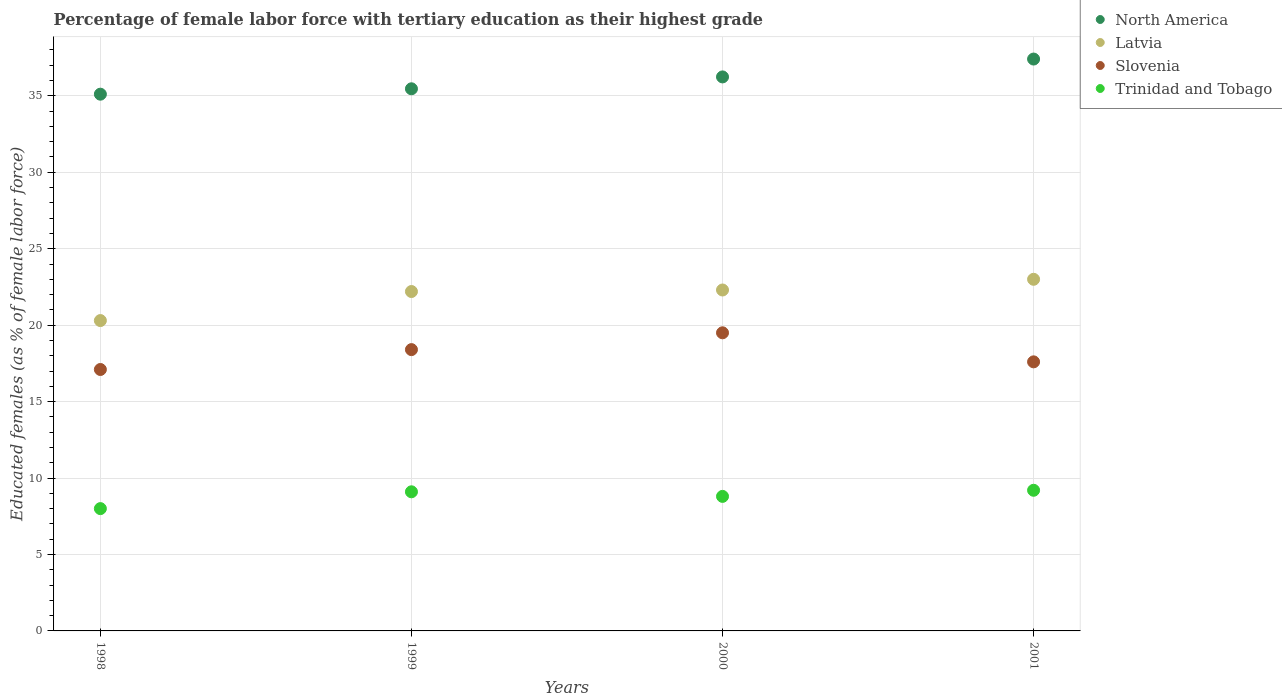How many different coloured dotlines are there?
Provide a short and direct response. 4. Is the number of dotlines equal to the number of legend labels?
Offer a very short reply. Yes. What is the percentage of female labor force with tertiary education in Slovenia in 2001?
Provide a short and direct response. 17.6. Across all years, what is the minimum percentage of female labor force with tertiary education in North America?
Give a very brief answer. 35.11. In which year was the percentage of female labor force with tertiary education in Latvia minimum?
Give a very brief answer. 1998. What is the total percentage of female labor force with tertiary education in North America in the graph?
Keep it short and to the point. 144.21. What is the difference between the percentage of female labor force with tertiary education in Trinidad and Tobago in 1998 and that in 2001?
Your response must be concise. -1.2. What is the difference between the percentage of female labor force with tertiary education in Trinidad and Tobago in 1998 and the percentage of female labor force with tertiary education in North America in 2001?
Your answer should be very brief. -29.41. What is the average percentage of female labor force with tertiary education in Trinidad and Tobago per year?
Your answer should be very brief. 8.78. In the year 2000, what is the difference between the percentage of female labor force with tertiary education in Slovenia and percentage of female labor force with tertiary education in Latvia?
Offer a terse response. -2.8. In how many years, is the percentage of female labor force with tertiary education in Slovenia greater than 12 %?
Provide a short and direct response. 4. What is the ratio of the percentage of female labor force with tertiary education in Latvia in 1998 to that in 2001?
Provide a succinct answer. 0.88. What is the difference between the highest and the second highest percentage of female labor force with tertiary education in Trinidad and Tobago?
Keep it short and to the point. 0.1. What is the difference between the highest and the lowest percentage of female labor force with tertiary education in Slovenia?
Your answer should be very brief. 2.4. In how many years, is the percentage of female labor force with tertiary education in Slovenia greater than the average percentage of female labor force with tertiary education in Slovenia taken over all years?
Provide a succinct answer. 2. Is the sum of the percentage of female labor force with tertiary education in North America in 1998 and 1999 greater than the maximum percentage of female labor force with tertiary education in Latvia across all years?
Offer a very short reply. Yes. Is it the case that in every year, the sum of the percentage of female labor force with tertiary education in Latvia and percentage of female labor force with tertiary education in Slovenia  is greater than the percentage of female labor force with tertiary education in Trinidad and Tobago?
Provide a succinct answer. Yes. Does the percentage of female labor force with tertiary education in Trinidad and Tobago monotonically increase over the years?
Ensure brevity in your answer.  No. Is the percentage of female labor force with tertiary education in North America strictly greater than the percentage of female labor force with tertiary education in Trinidad and Tobago over the years?
Your answer should be compact. Yes. Is the percentage of female labor force with tertiary education in North America strictly less than the percentage of female labor force with tertiary education in Slovenia over the years?
Provide a succinct answer. No. How many years are there in the graph?
Keep it short and to the point. 4. Does the graph contain any zero values?
Offer a very short reply. No. How are the legend labels stacked?
Your response must be concise. Vertical. What is the title of the graph?
Give a very brief answer. Percentage of female labor force with tertiary education as their highest grade. What is the label or title of the X-axis?
Make the answer very short. Years. What is the label or title of the Y-axis?
Offer a very short reply. Educated females (as % of female labor force). What is the Educated females (as % of female labor force) in North America in 1998?
Your answer should be very brief. 35.11. What is the Educated females (as % of female labor force) of Latvia in 1998?
Make the answer very short. 20.3. What is the Educated females (as % of female labor force) in Slovenia in 1998?
Your answer should be compact. 17.1. What is the Educated females (as % of female labor force) in North America in 1999?
Provide a short and direct response. 35.46. What is the Educated females (as % of female labor force) of Latvia in 1999?
Make the answer very short. 22.2. What is the Educated females (as % of female labor force) in Slovenia in 1999?
Your answer should be very brief. 18.4. What is the Educated females (as % of female labor force) in Trinidad and Tobago in 1999?
Your answer should be very brief. 9.1. What is the Educated females (as % of female labor force) in North America in 2000?
Your answer should be compact. 36.24. What is the Educated females (as % of female labor force) of Latvia in 2000?
Make the answer very short. 22.3. What is the Educated females (as % of female labor force) of Slovenia in 2000?
Your answer should be very brief. 19.5. What is the Educated females (as % of female labor force) in Trinidad and Tobago in 2000?
Make the answer very short. 8.8. What is the Educated females (as % of female labor force) in North America in 2001?
Offer a terse response. 37.41. What is the Educated females (as % of female labor force) of Latvia in 2001?
Offer a terse response. 23. What is the Educated females (as % of female labor force) of Slovenia in 2001?
Keep it short and to the point. 17.6. What is the Educated females (as % of female labor force) in Trinidad and Tobago in 2001?
Provide a short and direct response. 9.2. Across all years, what is the maximum Educated females (as % of female labor force) of North America?
Make the answer very short. 37.41. Across all years, what is the maximum Educated females (as % of female labor force) in Latvia?
Give a very brief answer. 23. Across all years, what is the maximum Educated females (as % of female labor force) in Slovenia?
Your answer should be very brief. 19.5. Across all years, what is the maximum Educated females (as % of female labor force) of Trinidad and Tobago?
Offer a very short reply. 9.2. Across all years, what is the minimum Educated females (as % of female labor force) of North America?
Your response must be concise. 35.11. Across all years, what is the minimum Educated females (as % of female labor force) in Latvia?
Offer a terse response. 20.3. Across all years, what is the minimum Educated females (as % of female labor force) in Slovenia?
Your answer should be very brief. 17.1. What is the total Educated females (as % of female labor force) in North America in the graph?
Provide a succinct answer. 144.21. What is the total Educated females (as % of female labor force) in Latvia in the graph?
Make the answer very short. 87.8. What is the total Educated females (as % of female labor force) of Slovenia in the graph?
Your response must be concise. 72.6. What is the total Educated females (as % of female labor force) of Trinidad and Tobago in the graph?
Your answer should be compact. 35.1. What is the difference between the Educated females (as % of female labor force) of North America in 1998 and that in 1999?
Give a very brief answer. -0.35. What is the difference between the Educated females (as % of female labor force) of Latvia in 1998 and that in 1999?
Provide a short and direct response. -1.9. What is the difference between the Educated females (as % of female labor force) of Trinidad and Tobago in 1998 and that in 1999?
Your response must be concise. -1.1. What is the difference between the Educated females (as % of female labor force) of North America in 1998 and that in 2000?
Give a very brief answer. -1.13. What is the difference between the Educated females (as % of female labor force) of Trinidad and Tobago in 1998 and that in 2000?
Your response must be concise. -0.8. What is the difference between the Educated females (as % of female labor force) in North America in 1998 and that in 2001?
Your answer should be very brief. -2.3. What is the difference between the Educated females (as % of female labor force) of Latvia in 1998 and that in 2001?
Your answer should be very brief. -2.7. What is the difference between the Educated females (as % of female labor force) of Slovenia in 1998 and that in 2001?
Your answer should be compact. -0.5. What is the difference between the Educated females (as % of female labor force) of Trinidad and Tobago in 1998 and that in 2001?
Your answer should be compact. -1.2. What is the difference between the Educated females (as % of female labor force) in North America in 1999 and that in 2000?
Offer a terse response. -0.78. What is the difference between the Educated females (as % of female labor force) in Latvia in 1999 and that in 2000?
Keep it short and to the point. -0.1. What is the difference between the Educated females (as % of female labor force) of North America in 1999 and that in 2001?
Offer a very short reply. -1.95. What is the difference between the Educated females (as % of female labor force) of Latvia in 1999 and that in 2001?
Give a very brief answer. -0.8. What is the difference between the Educated females (as % of female labor force) in Slovenia in 1999 and that in 2001?
Offer a terse response. 0.8. What is the difference between the Educated females (as % of female labor force) of North America in 2000 and that in 2001?
Provide a short and direct response. -1.17. What is the difference between the Educated females (as % of female labor force) of North America in 1998 and the Educated females (as % of female labor force) of Latvia in 1999?
Offer a terse response. 12.91. What is the difference between the Educated females (as % of female labor force) of North America in 1998 and the Educated females (as % of female labor force) of Slovenia in 1999?
Offer a terse response. 16.71. What is the difference between the Educated females (as % of female labor force) in North America in 1998 and the Educated females (as % of female labor force) in Trinidad and Tobago in 1999?
Provide a succinct answer. 26.01. What is the difference between the Educated females (as % of female labor force) in Slovenia in 1998 and the Educated females (as % of female labor force) in Trinidad and Tobago in 1999?
Give a very brief answer. 8. What is the difference between the Educated females (as % of female labor force) in North America in 1998 and the Educated females (as % of female labor force) in Latvia in 2000?
Make the answer very short. 12.81. What is the difference between the Educated females (as % of female labor force) of North America in 1998 and the Educated females (as % of female labor force) of Slovenia in 2000?
Your answer should be very brief. 15.61. What is the difference between the Educated females (as % of female labor force) of North America in 1998 and the Educated females (as % of female labor force) of Trinidad and Tobago in 2000?
Offer a terse response. 26.31. What is the difference between the Educated females (as % of female labor force) in North America in 1998 and the Educated females (as % of female labor force) in Latvia in 2001?
Make the answer very short. 12.11. What is the difference between the Educated females (as % of female labor force) in North America in 1998 and the Educated females (as % of female labor force) in Slovenia in 2001?
Provide a succinct answer. 17.51. What is the difference between the Educated females (as % of female labor force) of North America in 1998 and the Educated females (as % of female labor force) of Trinidad and Tobago in 2001?
Provide a succinct answer. 25.91. What is the difference between the Educated females (as % of female labor force) of Latvia in 1998 and the Educated females (as % of female labor force) of Trinidad and Tobago in 2001?
Give a very brief answer. 11.1. What is the difference between the Educated females (as % of female labor force) of North America in 1999 and the Educated females (as % of female labor force) of Latvia in 2000?
Give a very brief answer. 13.16. What is the difference between the Educated females (as % of female labor force) of North America in 1999 and the Educated females (as % of female labor force) of Slovenia in 2000?
Offer a very short reply. 15.96. What is the difference between the Educated females (as % of female labor force) in North America in 1999 and the Educated females (as % of female labor force) in Trinidad and Tobago in 2000?
Provide a succinct answer. 26.66. What is the difference between the Educated females (as % of female labor force) in Latvia in 1999 and the Educated females (as % of female labor force) in Trinidad and Tobago in 2000?
Your answer should be compact. 13.4. What is the difference between the Educated females (as % of female labor force) in North America in 1999 and the Educated females (as % of female labor force) in Latvia in 2001?
Your answer should be very brief. 12.46. What is the difference between the Educated females (as % of female labor force) in North America in 1999 and the Educated females (as % of female labor force) in Slovenia in 2001?
Your answer should be compact. 17.86. What is the difference between the Educated females (as % of female labor force) of North America in 1999 and the Educated females (as % of female labor force) of Trinidad and Tobago in 2001?
Offer a very short reply. 26.26. What is the difference between the Educated females (as % of female labor force) in Latvia in 1999 and the Educated females (as % of female labor force) in Trinidad and Tobago in 2001?
Offer a very short reply. 13. What is the difference between the Educated females (as % of female labor force) of Slovenia in 1999 and the Educated females (as % of female labor force) of Trinidad and Tobago in 2001?
Ensure brevity in your answer.  9.2. What is the difference between the Educated females (as % of female labor force) of North America in 2000 and the Educated females (as % of female labor force) of Latvia in 2001?
Provide a succinct answer. 13.24. What is the difference between the Educated females (as % of female labor force) in North America in 2000 and the Educated females (as % of female labor force) in Slovenia in 2001?
Your response must be concise. 18.64. What is the difference between the Educated females (as % of female labor force) of North America in 2000 and the Educated females (as % of female labor force) of Trinidad and Tobago in 2001?
Offer a very short reply. 27.04. What is the difference between the Educated females (as % of female labor force) in Latvia in 2000 and the Educated females (as % of female labor force) in Slovenia in 2001?
Your answer should be very brief. 4.7. What is the difference between the Educated females (as % of female labor force) of Latvia in 2000 and the Educated females (as % of female labor force) of Trinidad and Tobago in 2001?
Your answer should be very brief. 13.1. What is the difference between the Educated females (as % of female labor force) in Slovenia in 2000 and the Educated females (as % of female labor force) in Trinidad and Tobago in 2001?
Offer a terse response. 10.3. What is the average Educated females (as % of female labor force) in North America per year?
Make the answer very short. 36.05. What is the average Educated females (as % of female labor force) in Latvia per year?
Provide a short and direct response. 21.95. What is the average Educated females (as % of female labor force) in Slovenia per year?
Provide a short and direct response. 18.15. What is the average Educated females (as % of female labor force) of Trinidad and Tobago per year?
Provide a short and direct response. 8.78. In the year 1998, what is the difference between the Educated females (as % of female labor force) in North America and Educated females (as % of female labor force) in Latvia?
Make the answer very short. 14.81. In the year 1998, what is the difference between the Educated females (as % of female labor force) of North America and Educated females (as % of female labor force) of Slovenia?
Offer a very short reply. 18.01. In the year 1998, what is the difference between the Educated females (as % of female labor force) of North America and Educated females (as % of female labor force) of Trinidad and Tobago?
Keep it short and to the point. 27.11. In the year 1998, what is the difference between the Educated females (as % of female labor force) in Latvia and Educated females (as % of female labor force) in Slovenia?
Offer a very short reply. 3.2. In the year 1998, what is the difference between the Educated females (as % of female labor force) of Latvia and Educated females (as % of female labor force) of Trinidad and Tobago?
Offer a very short reply. 12.3. In the year 1999, what is the difference between the Educated females (as % of female labor force) in North America and Educated females (as % of female labor force) in Latvia?
Keep it short and to the point. 13.26. In the year 1999, what is the difference between the Educated females (as % of female labor force) of North America and Educated females (as % of female labor force) of Slovenia?
Provide a short and direct response. 17.06. In the year 1999, what is the difference between the Educated females (as % of female labor force) in North America and Educated females (as % of female labor force) in Trinidad and Tobago?
Give a very brief answer. 26.36. In the year 1999, what is the difference between the Educated females (as % of female labor force) in Latvia and Educated females (as % of female labor force) in Trinidad and Tobago?
Offer a terse response. 13.1. In the year 1999, what is the difference between the Educated females (as % of female labor force) of Slovenia and Educated females (as % of female labor force) of Trinidad and Tobago?
Your answer should be compact. 9.3. In the year 2000, what is the difference between the Educated females (as % of female labor force) of North America and Educated females (as % of female labor force) of Latvia?
Keep it short and to the point. 13.94. In the year 2000, what is the difference between the Educated females (as % of female labor force) of North America and Educated females (as % of female labor force) of Slovenia?
Your answer should be compact. 16.74. In the year 2000, what is the difference between the Educated females (as % of female labor force) in North America and Educated females (as % of female labor force) in Trinidad and Tobago?
Ensure brevity in your answer.  27.44. In the year 2000, what is the difference between the Educated females (as % of female labor force) in Latvia and Educated females (as % of female labor force) in Slovenia?
Offer a terse response. 2.8. In the year 2000, what is the difference between the Educated females (as % of female labor force) of Latvia and Educated females (as % of female labor force) of Trinidad and Tobago?
Give a very brief answer. 13.5. In the year 2001, what is the difference between the Educated females (as % of female labor force) of North America and Educated females (as % of female labor force) of Latvia?
Keep it short and to the point. 14.41. In the year 2001, what is the difference between the Educated females (as % of female labor force) in North America and Educated females (as % of female labor force) in Slovenia?
Ensure brevity in your answer.  19.81. In the year 2001, what is the difference between the Educated females (as % of female labor force) in North America and Educated females (as % of female labor force) in Trinidad and Tobago?
Give a very brief answer. 28.21. In the year 2001, what is the difference between the Educated females (as % of female labor force) in Latvia and Educated females (as % of female labor force) in Slovenia?
Keep it short and to the point. 5.4. In the year 2001, what is the difference between the Educated females (as % of female labor force) of Slovenia and Educated females (as % of female labor force) of Trinidad and Tobago?
Provide a short and direct response. 8.4. What is the ratio of the Educated females (as % of female labor force) in North America in 1998 to that in 1999?
Your response must be concise. 0.99. What is the ratio of the Educated females (as % of female labor force) in Latvia in 1998 to that in 1999?
Ensure brevity in your answer.  0.91. What is the ratio of the Educated females (as % of female labor force) in Slovenia in 1998 to that in 1999?
Give a very brief answer. 0.93. What is the ratio of the Educated females (as % of female labor force) of Trinidad and Tobago in 1998 to that in 1999?
Provide a succinct answer. 0.88. What is the ratio of the Educated females (as % of female labor force) in North America in 1998 to that in 2000?
Provide a short and direct response. 0.97. What is the ratio of the Educated females (as % of female labor force) of Latvia in 1998 to that in 2000?
Make the answer very short. 0.91. What is the ratio of the Educated females (as % of female labor force) in Slovenia in 1998 to that in 2000?
Your response must be concise. 0.88. What is the ratio of the Educated females (as % of female labor force) of North America in 1998 to that in 2001?
Your answer should be very brief. 0.94. What is the ratio of the Educated females (as % of female labor force) in Latvia in 1998 to that in 2001?
Offer a very short reply. 0.88. What is the ratio of the Educated females (as % of female labor force) in Slovenia in 1998 to that in 2001?
Provide a short and direct response. 0.97. What is the ratio of the Educated females (as % of female labor force) in Trinidad and Tobago in 1998 to that in 2001?
Offer a very short reply. 0.87. What is the ratio of the Educated females (as % of female labor force) of North America in 1999 to that in 2000?
Provide a succinct answer. 0.98. What is the ratio of the Educated females (as % of female labor force) in Latvia in 1999 to that in 2000?
Your response must be concise. 1. What is the ratio of the Educated females (as % of female labor force) of Slovenia in 1999 to that in 2000?
Give a very brief answer. 0.94. What is the ratio of the Educated females (as % of female labor force) of Trinidad and Tobago in 1999 to that in 2000?
Provide a succinct answer. 1.03. What is the ratio of the Educated females (as % of female labor force) of North America in 1999 to that in 2001?
Offer a very short reply. 0.95. What is the ratio of the Educated females (as % of female labor force) of Latvia in 1999 to that in 2001?
Provide a short and direct response. 0.97. What is the ratio of the Educated females (as % of female labor force) of Slovenia in 1999 to that in 2001?
Offer a terse response. 1.05. What is the ratio of the Educated females (as % of female labor force) in North America in 2000 to that in 2001?
Your response must be concise. 0.97. What is the ratio of the Educated females (as % of female labor force) of Latvia in 2000 to that in 2001?
Offer a very short reply. 0.97. What is the ratio of the Educated females (as % of female labor force) of Slovenia in 2000 to that in 2001?
Ensure brevity in your answer.  1.11. What is the ratio of the Educated females (as % of female labor force) in Trinidad and Tobago in 2000 to that in 2001?
Provide a succinct answer. 0.96. What is the difference between the highest and the second highest Educated females (as % of female labor force) in North America?
Offer a very short reply. 1.17. What is the difference between the highest and the second highest Educated females (as % of female labor force) in Latvia?
Your answer should be compact. 0.7. What is the difference between the highest and the second highest Educated females (as % of female labor force) of Slovenia?
Your answer should be very brief. 1.1. What is the difference between the highest and the second highest Educated females (as % of female labor force) of Trinidad and Tobago?
Your answer should be compact. 0.1. What is the difference between the highest and the lowest Educated females (as % of female labor force) in North America?
Offer a very short reply. 2.3. What is the difference between the highest and the lowest Educated females (as % of female labor force) of Latvia?
Provide a succinct answer. 2.7. 